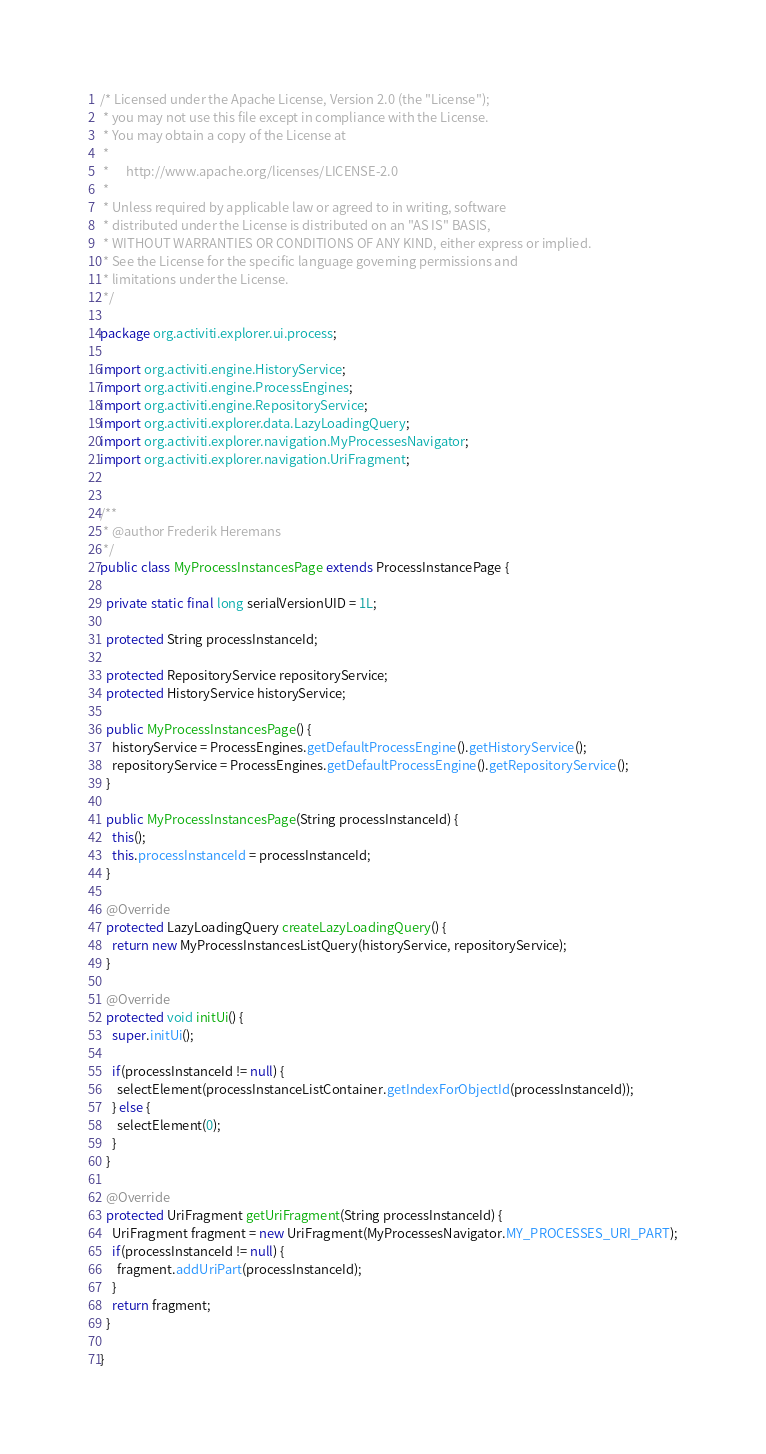<code> <loc_0><loc_0><loc_500><loc_500><_Java_>/* Licensed under the Apache License, Version 2.0 (the "License");
 * you may not use this file except in compliance with the License.
 * You may obtain a copy of the License at
 * 
 *      http://www.apache.org/licenses/LICENSE-2.0
 * 
 * Unless required by applicable law or agreed to in writing, software
 * distributed under the License is distributed on an "AS IS" BASIS,
 * WITHOUT WARRANTIES OR CONDITIONS OF ANY KIND, either express or implied.
 * See the License for the specific language governing permissions and
 * limitations under the License.
 */

package org.activiti.explorer.ui.process;

import org.activiti.engine.HistoryService;
import org.activiti.engine.ProcessEngines;
import org.activiti.engine.RepositoryService;
import org.activiti.explorer.data.LazyLoadingQuery;
import org.activiti.explorer.navigation.MyProcessesNavigator;
import org.activiti.explorer.navigation.UriFragment;


/**
 * @author Frederik Heremans
 */
public class MyProcessInstancesPage extends ProcessInstancePage {

  private static final long serialVersionUID = 1L;

  protected String processInstanceId;
  
  protected RepositoryService repositoryService;
  protected HistoryService historyService;
  
  public MyProcessInstancesPage() {
    historyService = ProcessEngines.getDefaultProcessEngine().getHistoryService();
    repositoryService = ProcessEngines.getDefaultProcessEngine().getRepositoryService();
  }
  
  public MyProcessInstancesPage(String processInstanceId) {
    this();
    this.processInstanceId = processInstanceId;
  }

  @Override
  protected LazyLoadingQuery createLazyLoadingQuery() {
    return new MyProcessInstancesListQuery(historyService, repositoryService);
  }
  
  @Override
  protected void initUi() {
    super.initUi();
    
    if(processInstanceId != null) {
      selectElement(processInstanceListContainer.getIndexForObjectId(processInstanceId));
    } else {
      selectElement(0);
    }
  }

  @Override
  protected UriFragment getUriFragment(String processInstanceId) {
    UriFragment fragment = new UriFragment(MyProcessesNavigator.MY_PROCESSES_URI_PART);
    if(processInstanceId != null) {
      fragment.addUriPart(processInstanceId);
    }
    return fragment;
  }
  
}
</code> 